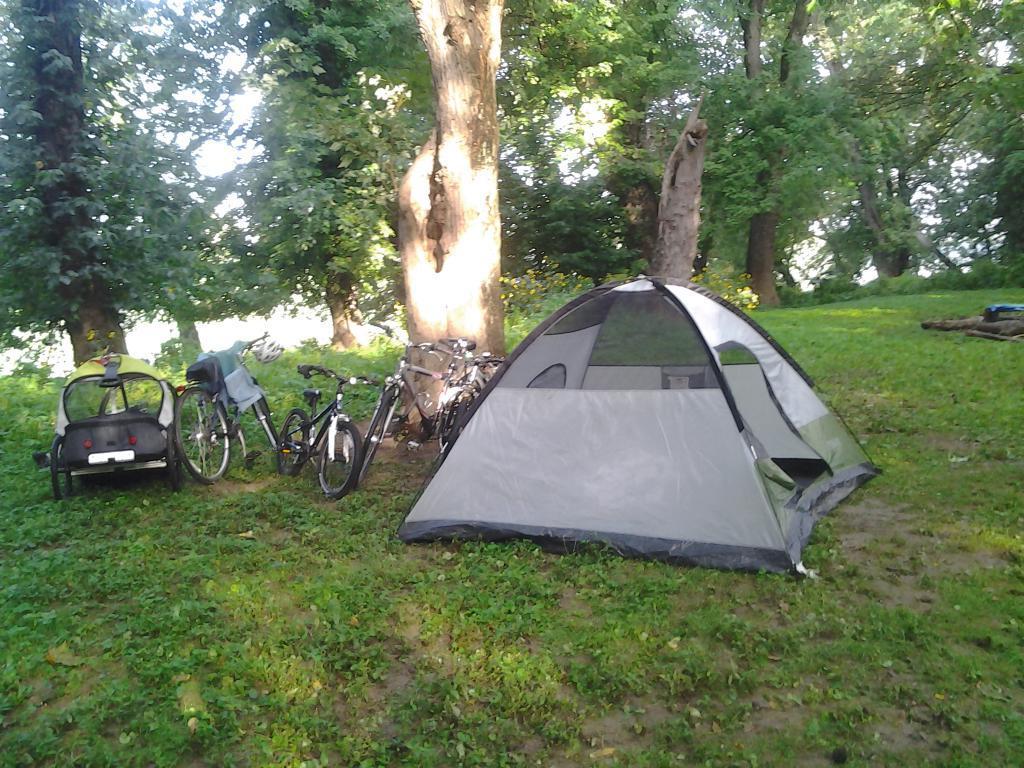Could you give a brief overview of what you see in this image? In this image I can see a tent and some bicycles in a forest with trees. 